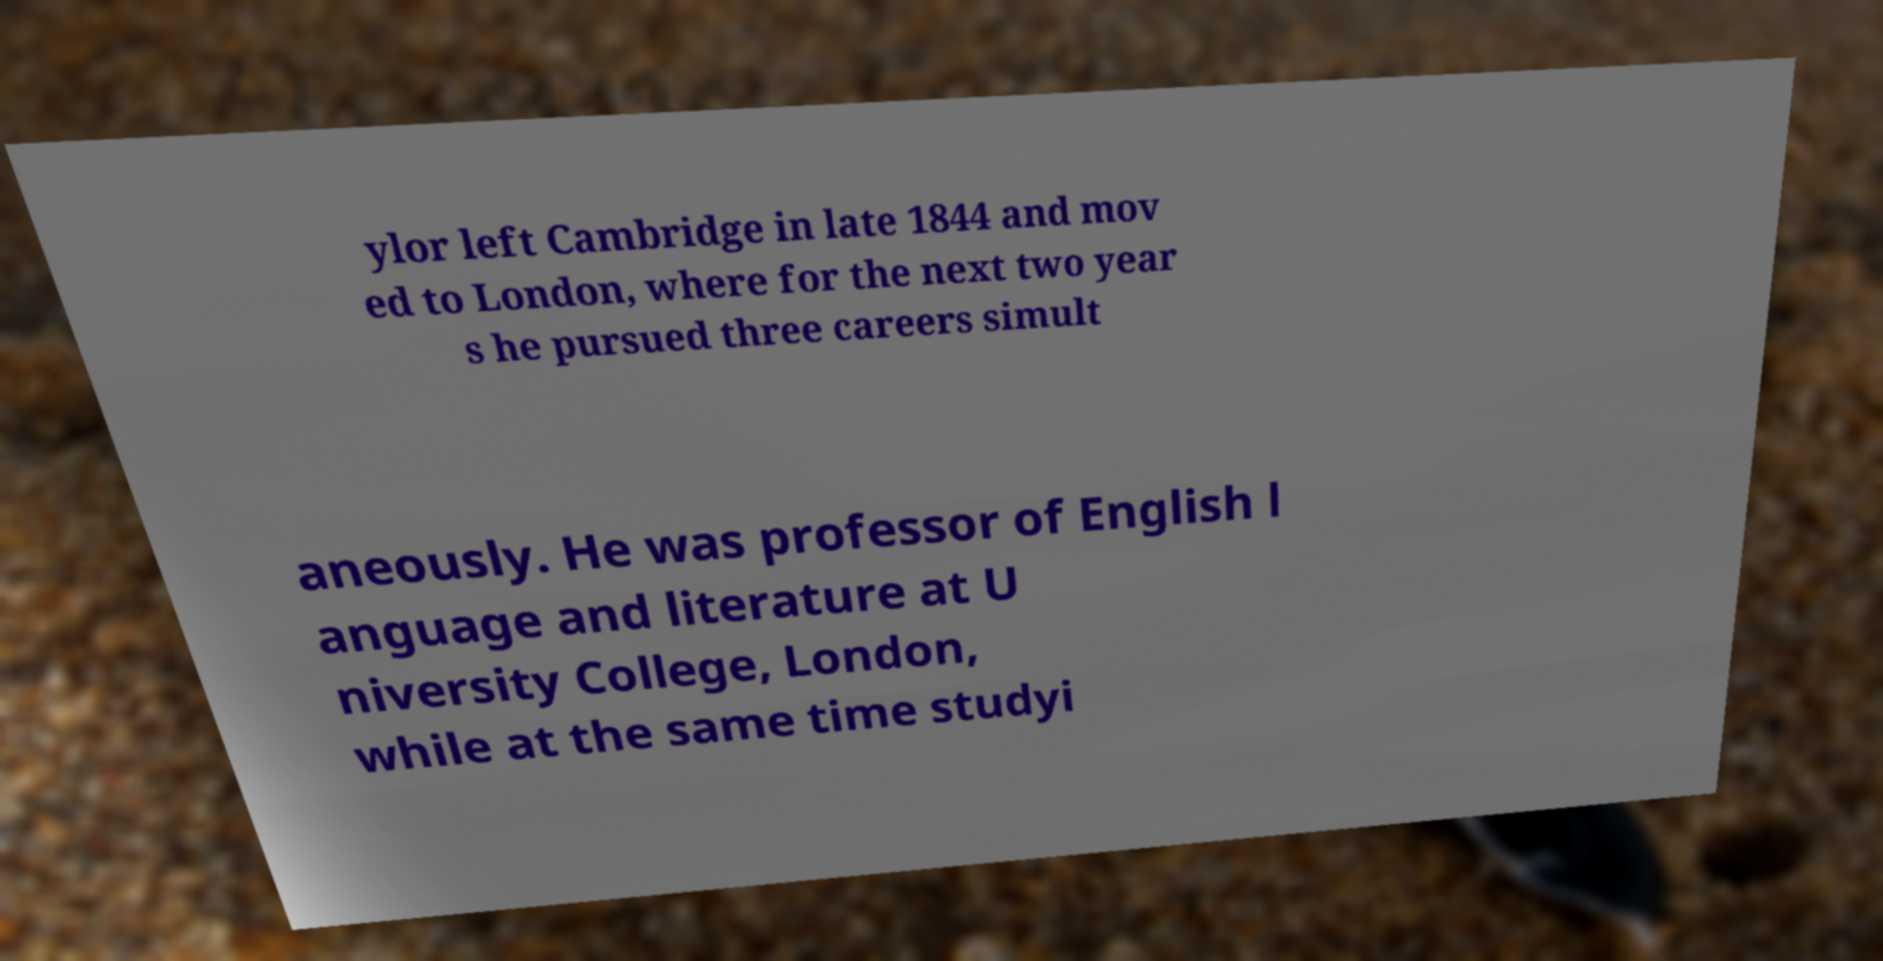Could you extract and type out the text from this image? ylor left Cambridge in late 1844 and mov ed to London, where for the next two year s he pursued three careers simult aneously. He was professor of English l anguage and literature at U niversity College, London, while at the same time studyi 